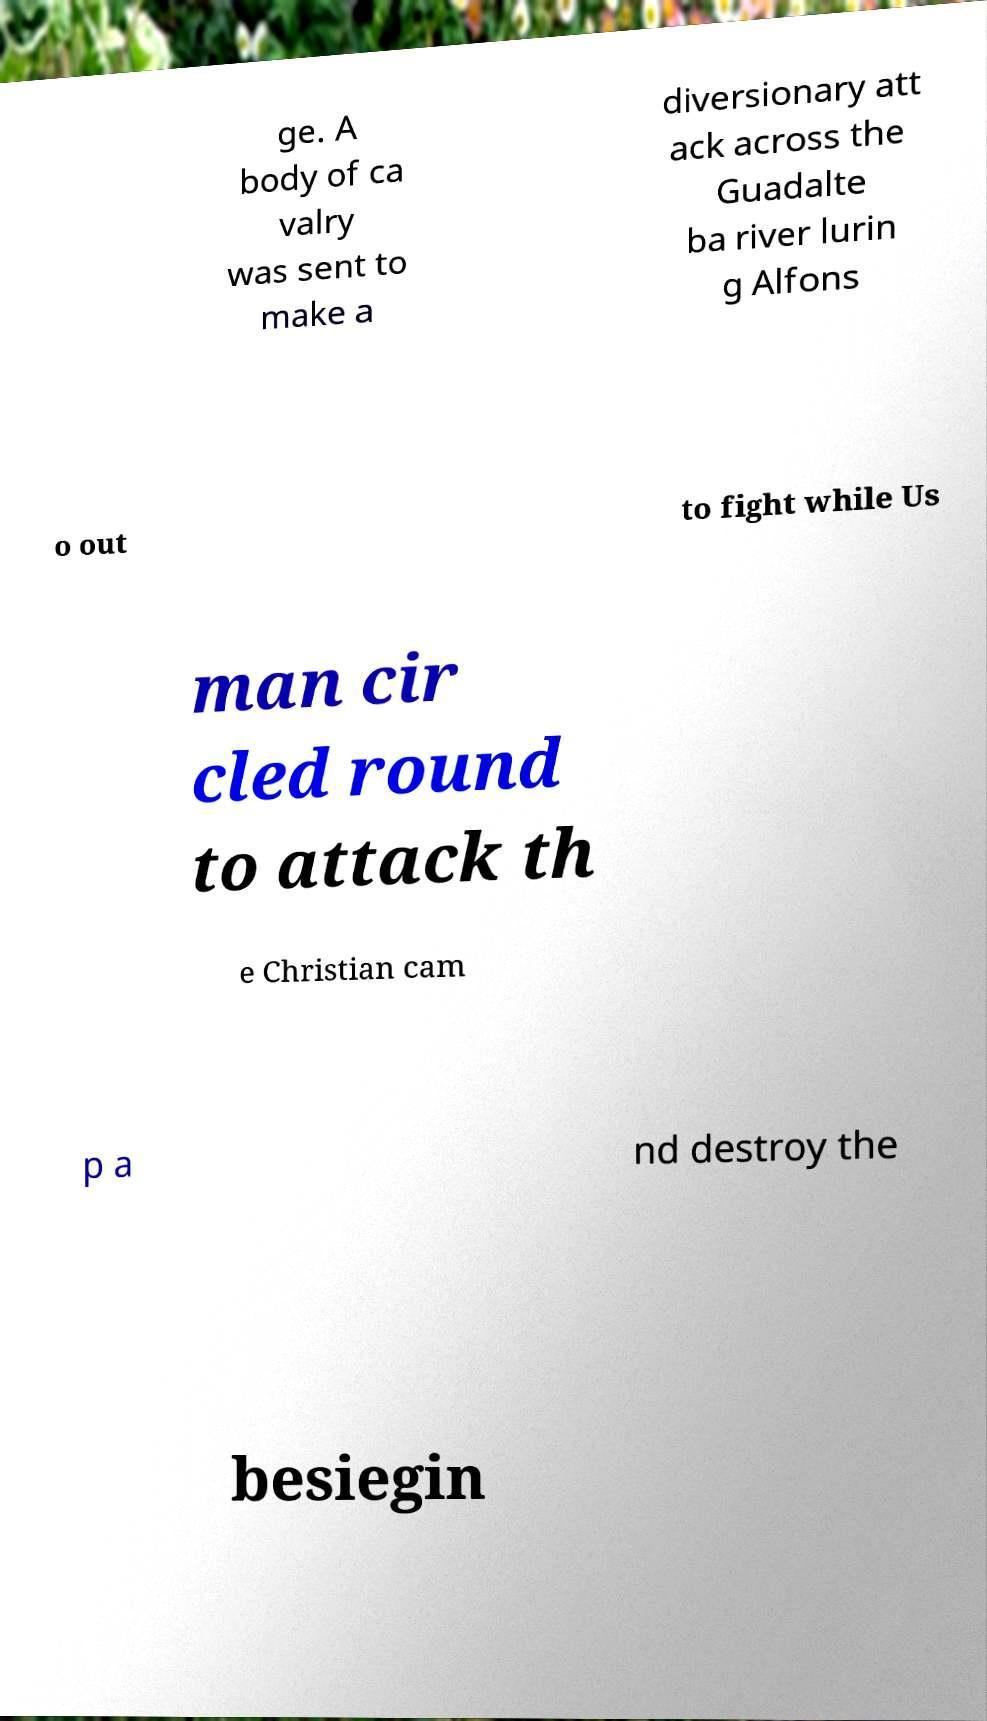Could you extract and type out the text from this image? ge. A body of ca valry was sent to make a diversionary att ack across the Guadalte ba river lurin g Alfons o out to fight while Us man cir cled round to attack th e Christian cam p a nd destroy the besiegin 